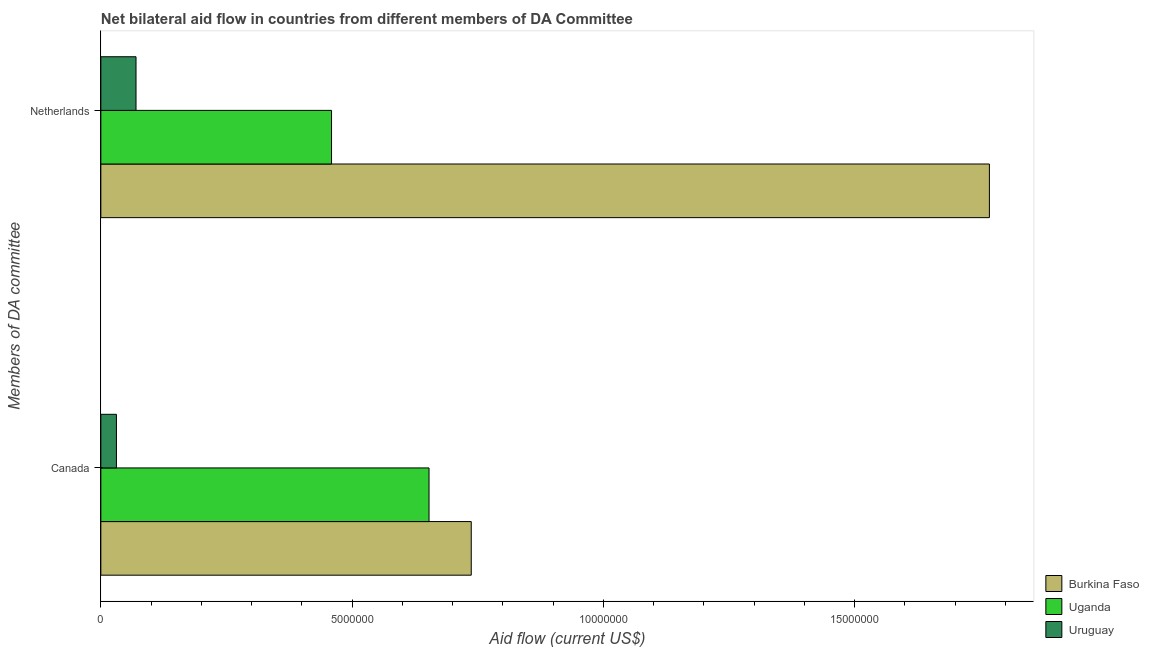How many different coloured bars are there?
Ensure brevity in your answer.  3. Are the number of bars on each tick of the Y-axis equal?
Give a very brief answer. Yes. How many bars are there on the 1st tick from the top?
Your answer should be compact. 3. What is the label of the 1st group of bars from the top?
Your answer should be very brief. Netherlands. What is the amount of aid given by canada in Uganda?
Make the answer very short. 6.53e+06. Across all countries, what is the maximum amount of aid given by canada?
Offer a very short reply. 7.37e+06. Across all countries, what is the minimum amount of aid given by canada?
Keep it short and to the point. 3.10e+05. In which country was the amount of aid given by canada maximum?
Ensure brevity in your answer.  Burkina Faso. In which country was the amount of aid given by canada minimum?
Your response must be concise. Uruguay. What is the total amount of aid given by netherlands in the graph?
Offer a very short reply. 2.30e+07. What is the difference between the amount of aid given by canada in Burkina Faso and that in Uganda?
Provide a short and direct response. 8.40e+05. What is the difference between the amount of aid given by canada in Burkina Faso and the amount of aid given by netherlands in Uganda?
Your answer should be very brief. 2.78e+06. What is the average amount of aid given by netherlands per country?
Give a very brief answer. 7.66e+06. What is the difference between the amount of aid given by netherlands and amount of aid given by canada in Uruguay?
Offer a very short reply. 3.90e+05. In how many countries, is the amount of aid given by canada greater than 8000000 US$?
Your answer should be very brief. 0. What is the ratio of the amount of aid given by netherlands in Burkina Faso to that in Uruguay?
Your answer should be very brief. 25.26. In how many countries, is the amount of aid given by netherlands greater than the average amount of aid given by netherlands taken over all countries?
Your answer should be compact. 1. What does the 2nd bar from the top in Canada represents?
Offer a terse response. Uganda. What does the 3rd bar from the bottom in Netherlands represents?
Ensure brevity in your answer.  Uruguay. How many bars are there?
Make the answer very short. 6. What is the difference between two consecutive major ticks on the X-axis?
Ensure brevity in your answer.  5.00e+06. Does the graph contain any zero values?
Your answer should be very brief. No. Where does the legend appear in the graph?
Give a very brief answer. Bottom right. What is the title of the graph?
Keep it short and to the point. Net bilateral aid flow in countries from different members of DA Committee. Does "St. Lucia" appear as one of the legend labels in the graph?
Your answer should be compact. No. What is the label or title of the Y-axis?
Ensure brevity in your answer.  Members of DA committee. What is the Aid flow (current US$) of Burkina Faso in Canada?
Provide a short and direct response. 7.37e+06. What is the Aid flow (current US$) of Uganda in Canada?
Provide a succinct answer. 6.53e+06. What is the Aid flow (current US$) of Uruguay in Canada?
Your answer should be compact. 3.10e+05. What is the Aid flow (current US$) of Burkina Faso in Netherlands?
Offer a terse response. 1.77e+07. What is the Aid flow (current US$) in Uganda in Netherlands?
Keep it short and to the point. 4.59e+06. Across all Members of DA committee, what is the maximum Aid flow (current US$) in Burkina Faso?
Ensure brevity in your answer.  1.77e+07. Across all Members of DA committee, what is the maximum Aid flow (current US$) in Uganda?
Your response must be concise. 6.53e+06. Across all Members of DA committee, what is the maximum Aid flow (current US$) in Uruguay?
Offer a very short reply. 7.00e+05. Across all Members of DA committee, what is the minimum Aid flow (current US$) of Burkina Faso?
Provide a succinct answer. 7.37e+06. Across all Members of DA committee, what is the minimum Aid flow (current US$) of Uganda?
Offer a very short reply. 4.59e+06. What is the total Aid flow (current US$) in Burkina Faso in the graph?
Your response must be concise. 2.50e+07. What is the total Aid flow (current US$) of Uganda in the graph?
Ensure brevity in your answer.  1.11e+07. What is the total Aid flow (current US$) of Uruguay in the graph?
Your response must be concise. 1.01e+06. What is the difference between the Aid flow (current US$) in Burkina Faso in Canada and that in Netherlands?
Provide a succinct answer. -1.03e+07. What is the difference between the Aid flow (current US$) in Uganda in Canada and that in Netherlands?
Your answer should be very brief. 1.94e+06. What is the difference between the Aid flow (current US$) in Uruguay in Canada and that in Netherlands?
Make the answer very short. -3.90e+05. What is the difference between the Aid flow (current US$) of Burkina Faso in Canada and the Aid flow (current US$) of Uganda in Netherlands?
Your answer should be compact. 2.78e+06. What is the difference between the Aid flow (current US$) in Burkina Faso in Canada and the Aid flow (current US$) in Uruguay in Netherlands?
Ensure brevity in your answer.  6.67e+06. What is the difference between the Aid flow (current US$) of Uganda in Canada and the Aid flow (current US$) of Uruguay in Netherlands?
Give a very brief answer. 5.83e+06. What is the average Aid flow (current US$) in Burkina Faso per Members of DA committee?
Keep it short and to the point. 1.25e+07. What is the average Aid flow (current US$) of Uganda per Members of DA committee?
Make the answer very short. 5.56e+06. What is the average Aid flow (current US$) in Uruguay per Members of DA committee?
Your answer should be very brief. 5.05e+05. What is the difference between the Aid flow (current US$) in Burkina Faso and Aid flow (current US$) in Uganda in Canada?
Provide a short and direct response. 8.40e+05. What is the difference between the Aid flow (current US$) of Burkina Faso and Aid flow (current US$) of Uruguay in Canada?
Provide a short and direct response. 7.06e+06. What is the difference between the Aid flow (current US$) in Uganda and Aid flow (current US$) in Uruguay in Canada?
Your answer should be very brief. 6.22e+06. What is the difference between the Aid flow (current US$) in Burkina Faso and Aid flow (current US$) in Uganda in Netherlands?
Make the answer very short. 1.31e+07. What is the difference between the Aid flow (current US$) in Burkina Faso and Aid flow (current US$) in Uruguay in Netherlands?
Your response must be concise. 1.70e+07. What is the difference between the Aid flow (current US$) in Uganda and Aid flow (current US$) in Uruguay in Netherlands?
Make the answer very short. 3.89e+06. What is the ratio of the Aid flow (current US$) of Burkina Faso in Canada to that in Netherlands?
Your answer should be very brief. 0.42. What is the ratio of the Aid flow (current US$) in Uganda in Canada to that in Netherlands?
Your answer should be very brief. 1.42. What is the ratio of the Aid flow (current US$) of Uruguay in Canada to that in Netherlands?
Provide a short and direct response. 0.44. What is the difference between the highest and the second highest Aid flow (current US$) in Burkina Faso?
Offer a very short reply. 1.03e+07. What is the difference between the highest and the second highest Aid flow (current US$) in Uganda?
Make the answer very short. 1.94e+06. What is the difference between the highest and the lowest Aid flow (current US$) of Burkina Faso?
Ensure brevity in your answer.  1.03e+07. What is the difference between the highest and the lowest Aid flow (current US$) of Uganda?
Provide a short and direct response. 1.94e+06. 